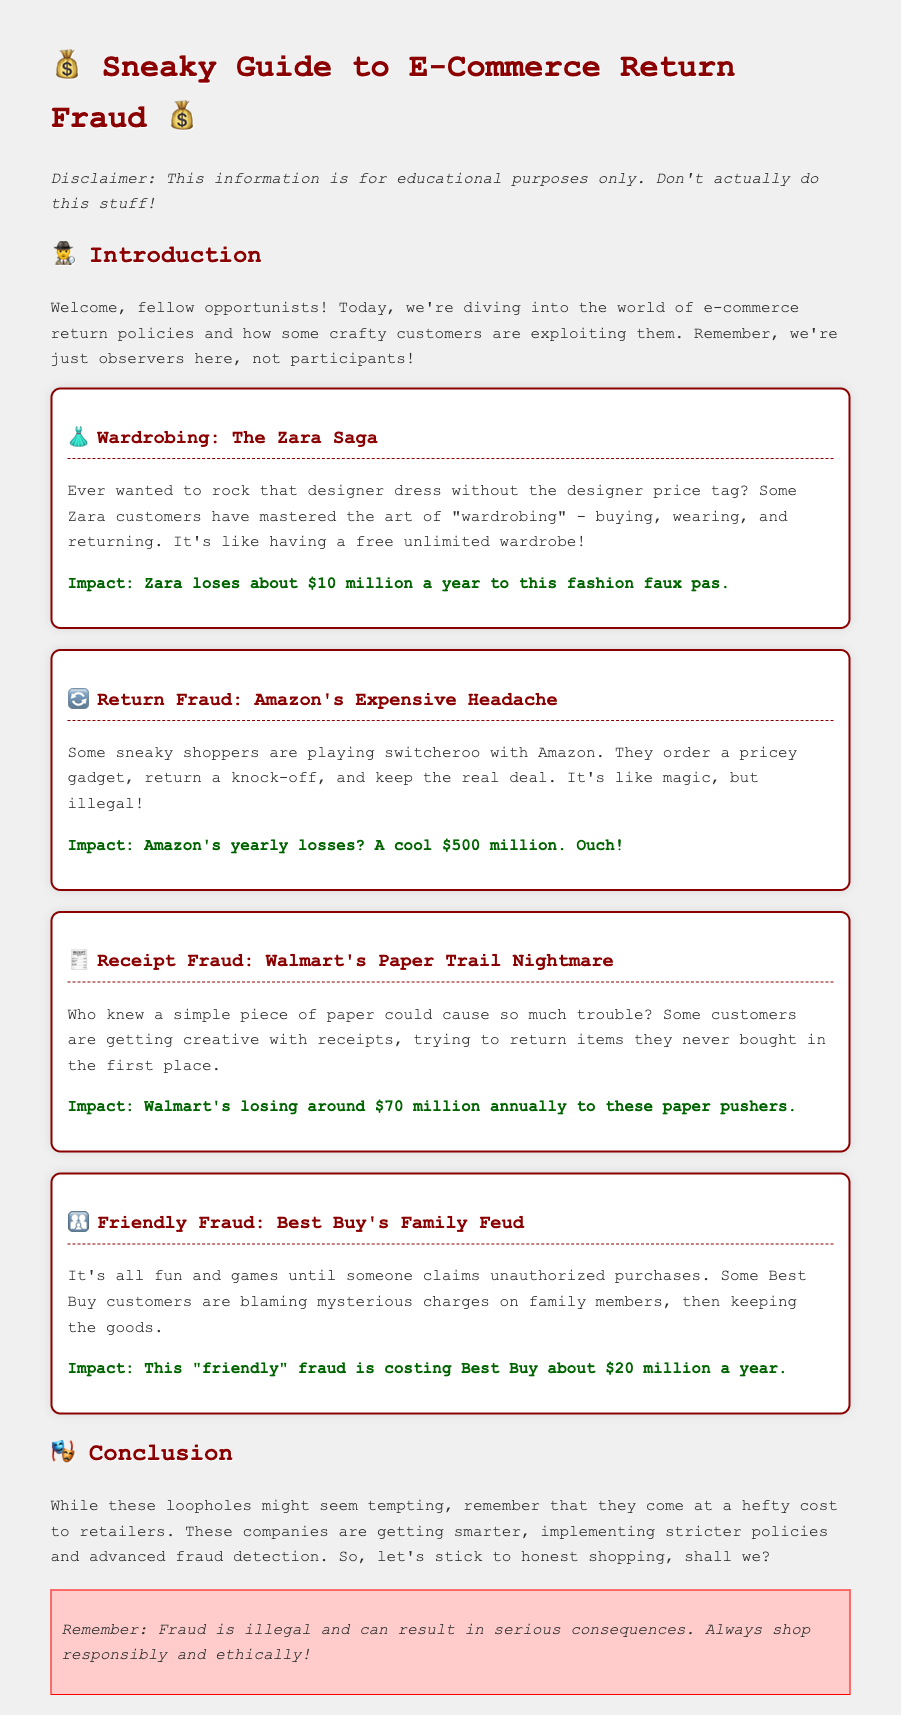What is the title of the document? The title is stated in the heading of the document, which is "Sneaky Guide to E-Commerce Return Fraud."
Answer: Sneaky Guide to E-Commerce Return Fraud How much does Zara lose annually due to wardrobing? The impact of wardrobing on Zara's finances is directly mentioned as losing about $10 million a year.
Answer: $10 million What is the financial impact of return fraud on Amazon? The document specifies Amazon's yearly losses due to return fraud as a significant figure mentioned explicitly.
Answer: $500 million What fraudulent practice is related to Walmart receipts? The practice described in relation to Walmart involves customers returning items they never bought using altered or fake receipts.
Answer: Receipt Fraud Which retailer experiences "friendly fraud"? The document explicitly mentions Best Buy being the company linked to "friendly fraud."
Answer: Best Buy What is the concluding advice given in the document? The conclusion suggests a general message against exploiting these loopholes and encourages responsible shopping behaviors.
Answer: Shop responsibly and ethically How much is Best Buy losing to friendly fraud annually? The document provides a specific financial impact for Best Buy due to friendly fraud, clearly stated.
Answer: $20 million What is the main theme discussed in the document? The document focuses on various methods customers use to exploit e-commerce return policies and the resulting financial impacts on retailers.
Answer: Return fraud 